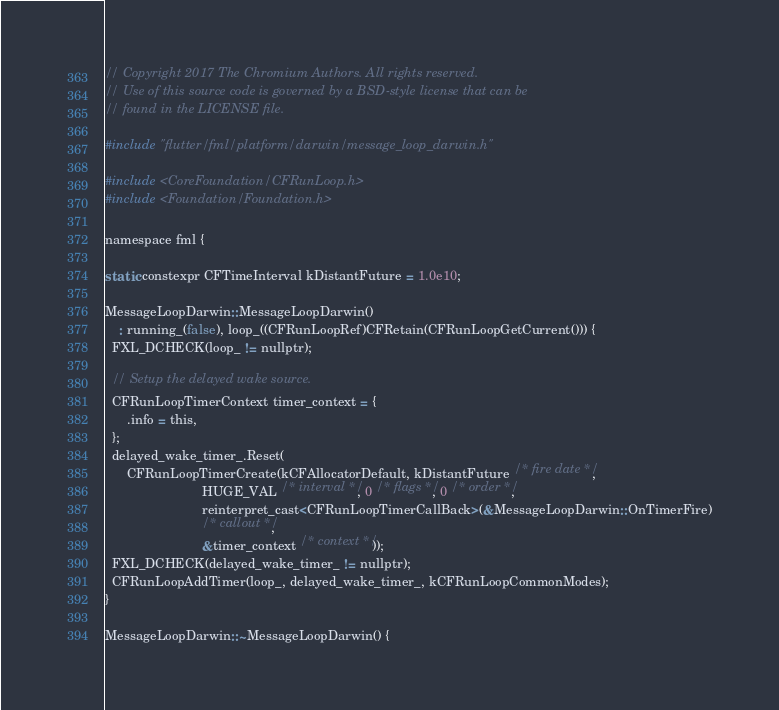<code> <loc_0><loc_0><loc_500><loc_500><_ObjectiveC_>// Copyright 2017 The Chromium Authors. All rights reserved.
// Use of this source code is governed by a BSD-style license that can be
// found in the LICENSE file.

#include "flutter/fml/platform/darwin/message_loop_darwin.h"

#include <CoreFoundation/CFRunLoop.h>
#include <Foundation/Foundation.h>

namespace fml {

static constexpr CFTimeInterval kDistantFuture = 1.0e10;

MessageLoopDarwin::MessageLoopDarwin()
    : running_(false), loop_((CFRunLoopRef)CFRetain(CFRunLoopGetCurrent())) {
  FXL_DCHECK(loop_ != nullptr);

  // Setup the delayed wake source.
  CFRunLoopTimerContext timer_context = {
      .info = this,
  };
  delayed_wake_timer_.Reset(
      CFRunLoopTimerCreate(kCFAllocatorDefault, kDistantFuture /* fire date */,
                           HUGE_VAL /* interval */, 0 /* flags */, 0 /* order */,
                           reinterpret_cast<CFRunLoopTimerCallBack>(&MessageLoopDarwin::OnTimerFire)
                           /* callout */,
                           &timer_context /* context */));
  FXL_DCHECK(delayed_wake_timer_ != nullptr);
  CFRunLoopAddTimer(loop_, delayed_wake_timer_, kCFRunLoopCommonModes);
}

MessageLoopDarwin::~MessageLoopDarwin() {</code> 